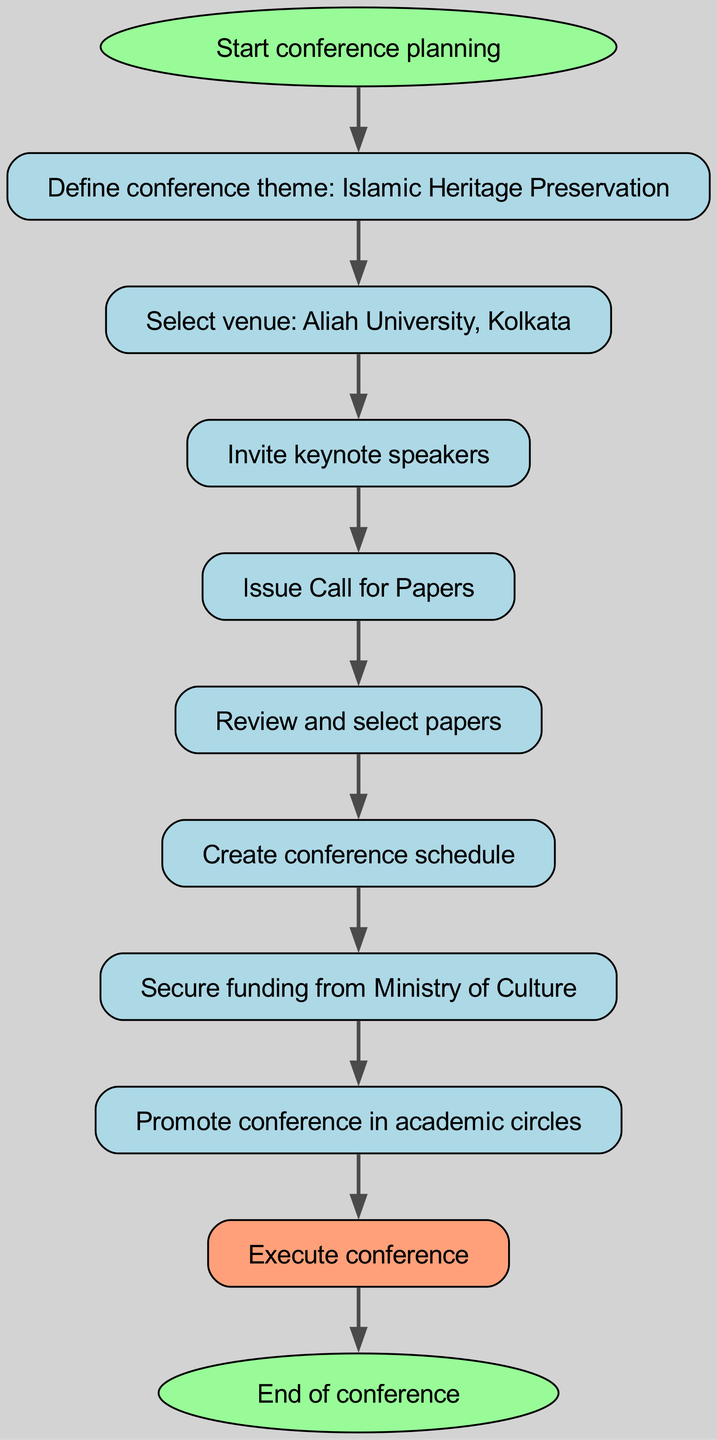What is the first step in the conference planning workflow? The first step, indicated by the 'start' node, is "Start conference planning."
Answer: Start conference planning How many total nodes are there in the diagram? By counting the nodes listed, there are a total of 11 nodes in the diagram, including 'start' and 'end.'
Answer: 11 What is the last action taken before the conference ends? The last action taken before reaching the 'end' node is "Execute conference." This can be found by tracing the flow from 'execute' to 'end.'
Answer: Execute conference What node comes after "Secure funding from Ministry of Culture"? The node that comes directly after "Secure funding from Ministry of Culture" is "Promote conference in academic circles," as indicated by the connection in the diagram.
Answer: Promote conference in academic circles Which organization is targeted for funding? The organization targeted for funding, as indicated in the node, is the "Ministry of Culture."
Answer: Ministry of Culture What theme is defined for the conference? The theme defined for the conference, as specified in the 'theme' node, is "Islamic Heritage Preservation."
Answer: Islamic Heritage Preservation If a paper is reviewed and accepted, what is the next step? After reviewing and selecting papers, the next step in the flow is to "Create conference schedule," as shown by the link from the 'review' node.
Answer: Create conference schedule What shape is used to represent the 'start' and 'end' nodes? The 'start' and 'end' nodes are represented by oval shapes, which differentiates them from the other nodes in the diagram.
Answer: Oval How are the keynotes invited after selecting the venue? After selecting the venue, the action taken is to "Invite keynote speakers," and this follows directly in the flow from 'venue' to 'speakers.'
Answer: Invite keynote speakers What action comes immediately before issuing the Call for Papers? The action that comes immediately before issuing the Call for Papers is "Invite keynote speakers," as the diagram flows sequentially from 'speakers' to 'cfp.'
Answer: Invite keynote speakers 